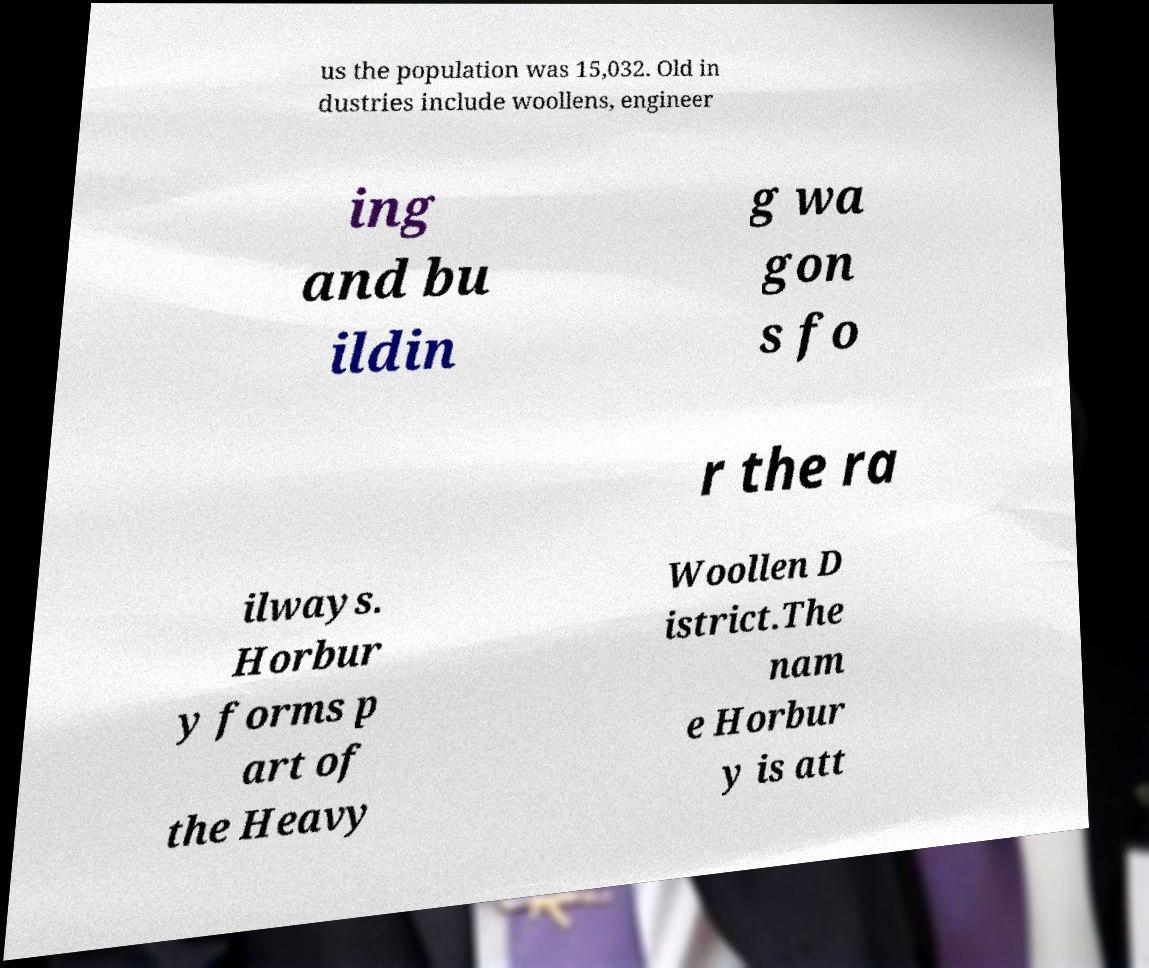I need the written content from this picture converted into text. Can you do that? us the population was 15,032. Old in dustries include woollens, engineer ing and bu ildin g wa gon s fo r the ra ilways. Horbur y forms p art of the Heavy Woollen D istrict.The nam e Horbur y is att 